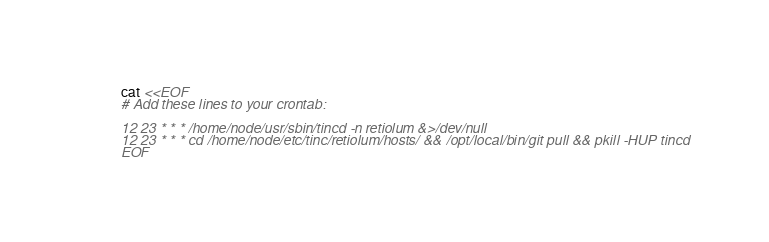<code> <loc_0><loc_0><loc_500><loc_500><_Bash_>cat <<EOF
# Add these lines to your crontab:

12 23 * * * /home/node/usr/sbin/tincd -n retiolum &>/dev/null
12 23 * * * cd /home/node/etc/tinc/retiolum/hosts/ && /opt/local/bin/git pull && pkill -HUP tincd
EOF

</code> 